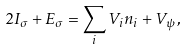Convert formula to latex. <formula><loc_0><loc_0><loc_500><loc_500>2 I _ { \sigma } + E _ { \sigma } = \sum _ { i } V _ { i } n _ { i } + V _ { \psi } \, ,</formula> 